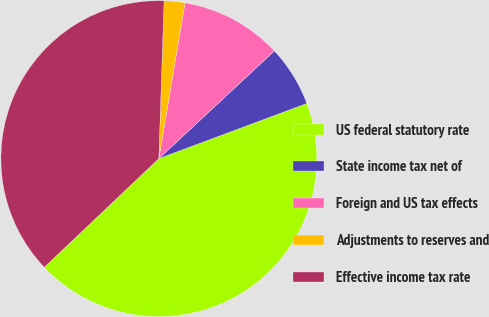<chart> <loc_0><loc_0><loc_500><loc_500><pie_chart><fcel>US federal statutory rate<fcel>State income tax net of<fcel>Foreign and US tax effects<fcel>Adjustments to reserves and<fcel>Effective income tax rate<nl><fcel>43.59%<fcel>6.26%<fcel>10.41%<fcel>2.12%<fcel>37.61%<nl></chart> 